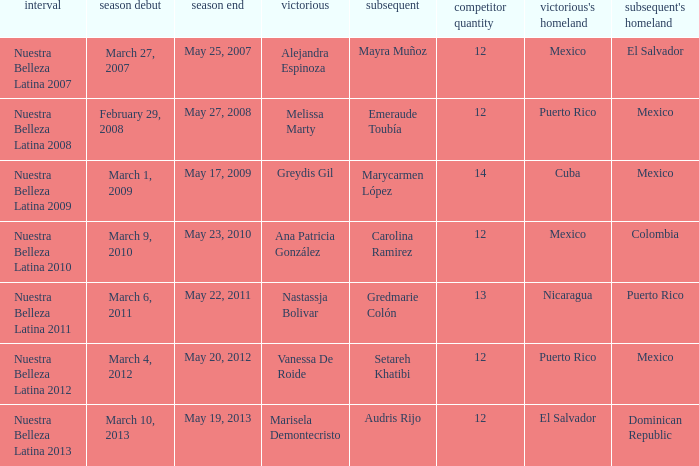How many contestants were there on March 1, 2009 during the season premiere? 14.0. 